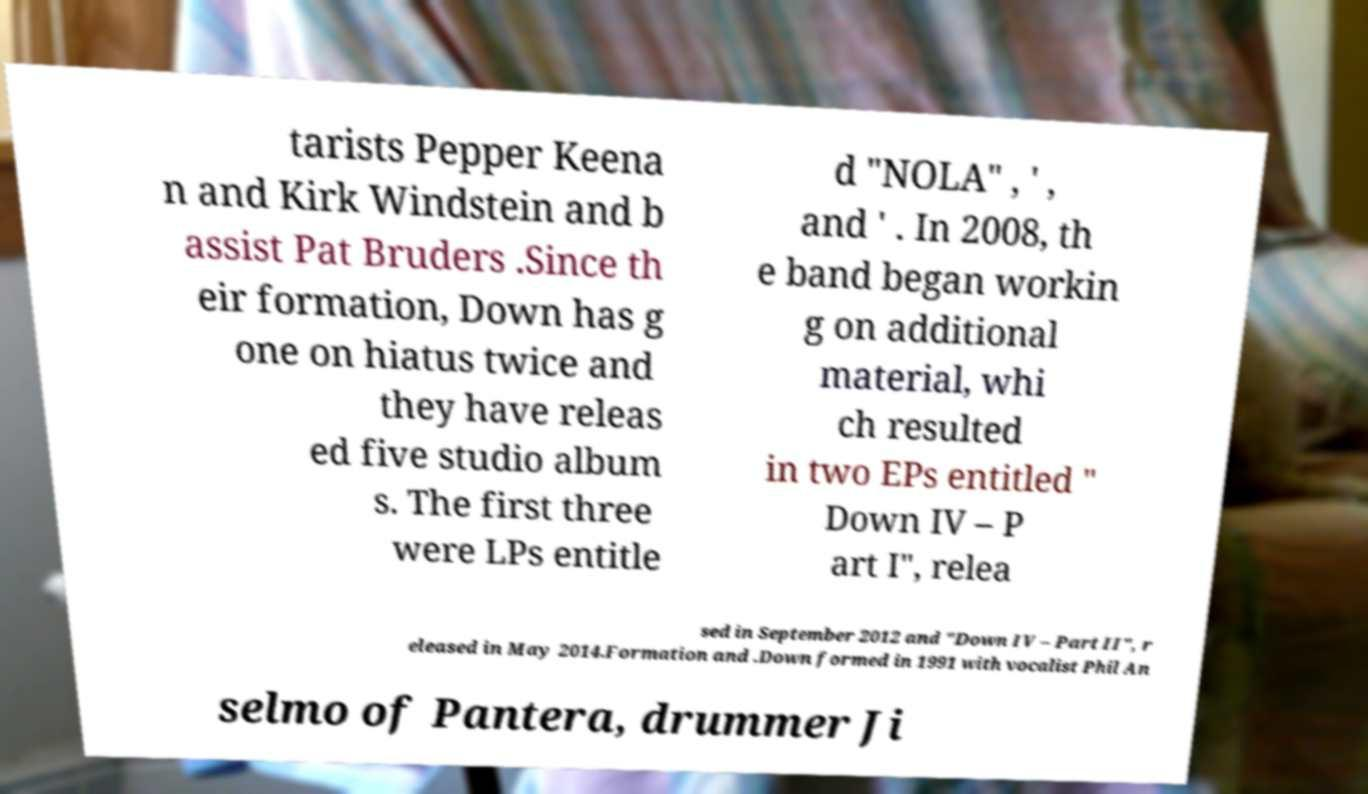For documentation purposes, I need the text within this image transcribed. Could you provide that? tarists Pepper Keena n and Kirk Windstein and b assist Pat Bruders .Since th eir formation, Down has g one on hiatus twice and they have releas ed five studio album s. The first three were LPs entitle d "NOLA" , ' , and ' . In 2008, th e band began workin g on additional material, whi ch resulted in two EPs entitled " Down IV – P art I", relea sed in September 2012 and "Down IV – Part II", r eleased in May 2014.Formation and .Down formed in 1991 with vocalist Phil An selmo of Pantera, drummer Ji 